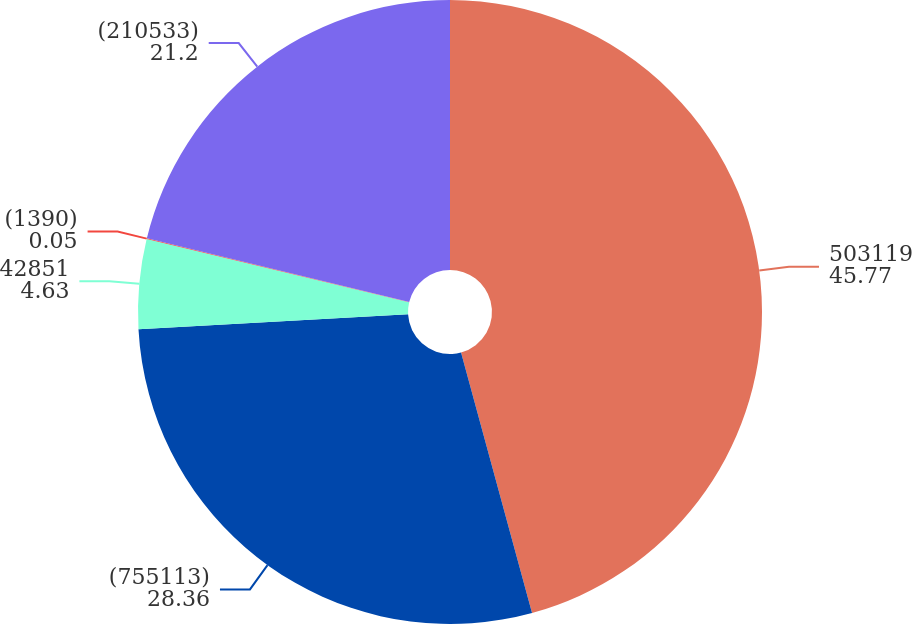Convert chart. <chart><loc_0><loc_0><loc_500><loc_500><pie_chart><fcel>503119<fcel>(755113)<fcel>42851<fcel>(1390)<fcel>(210533)<nl><fcel>45.77%<fcel>28.36%<fcel>4.63%<fcel>0.05%<fcel>21.2%<nl></chart> 